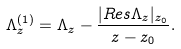Convert formula to latex. <formula><loc_0><loc_0><loc_500><loc_500>\Lambda ^ { ( 1 ) } _ { z } = \Lambda _ { z } - \frac { | R e s \Lambda _ { z } | _ { z _ { 0 } } } { z - z _ { 0 } } .</formula> 